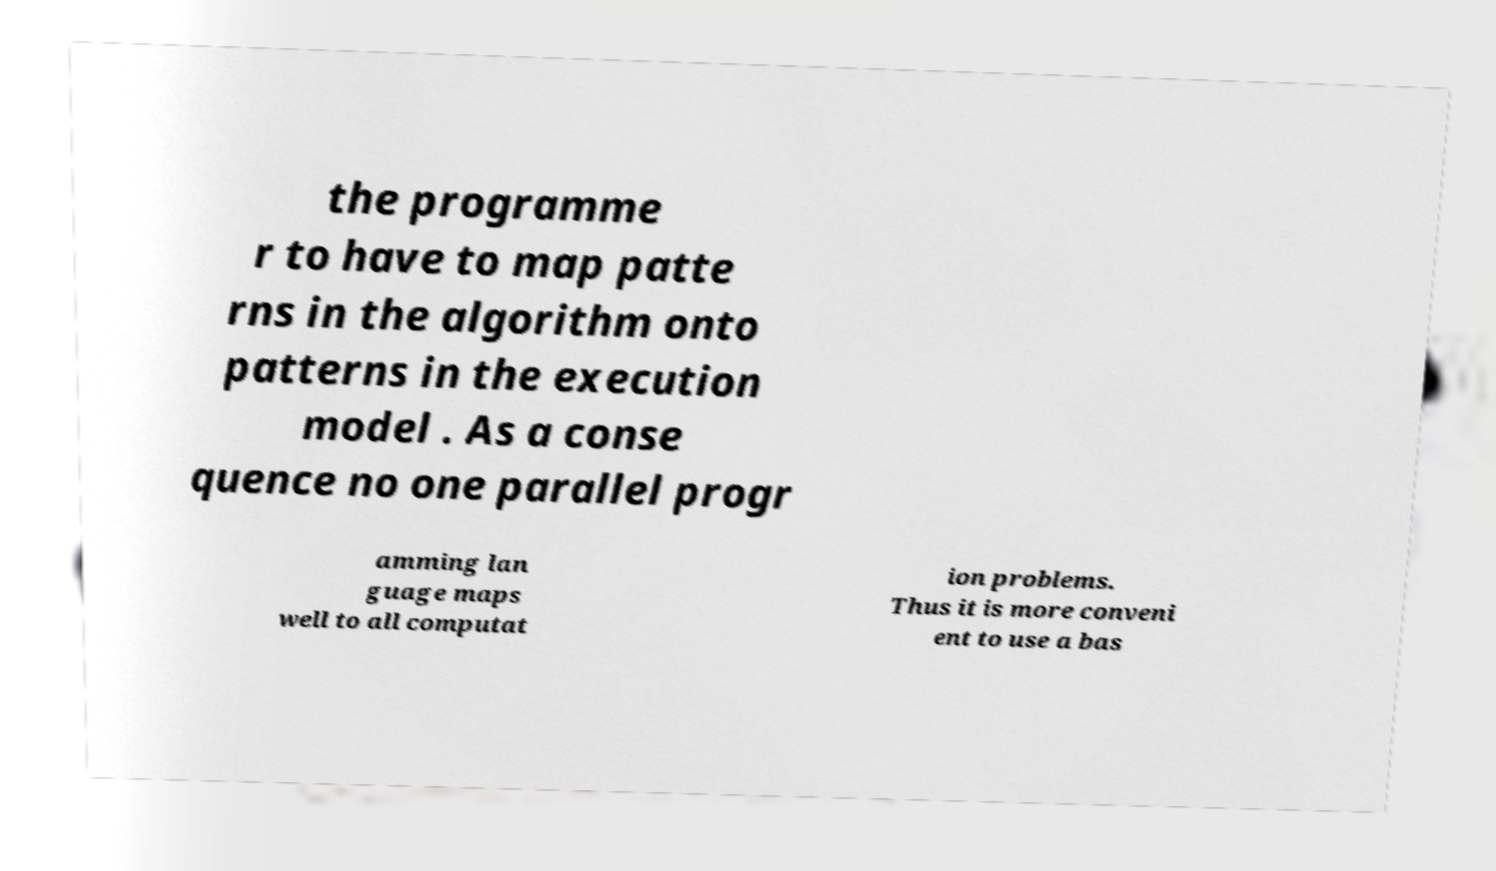There's text embedded in this image that I need extracted. Can you transcribe it verbatim? the programme r to have to map patte rns in the algorithm onto patterns in the execution model . As a conse quence no one parallel progr amming lan guage maps well to all computat ion problems. Thus it is more conveni ent to use a bas 